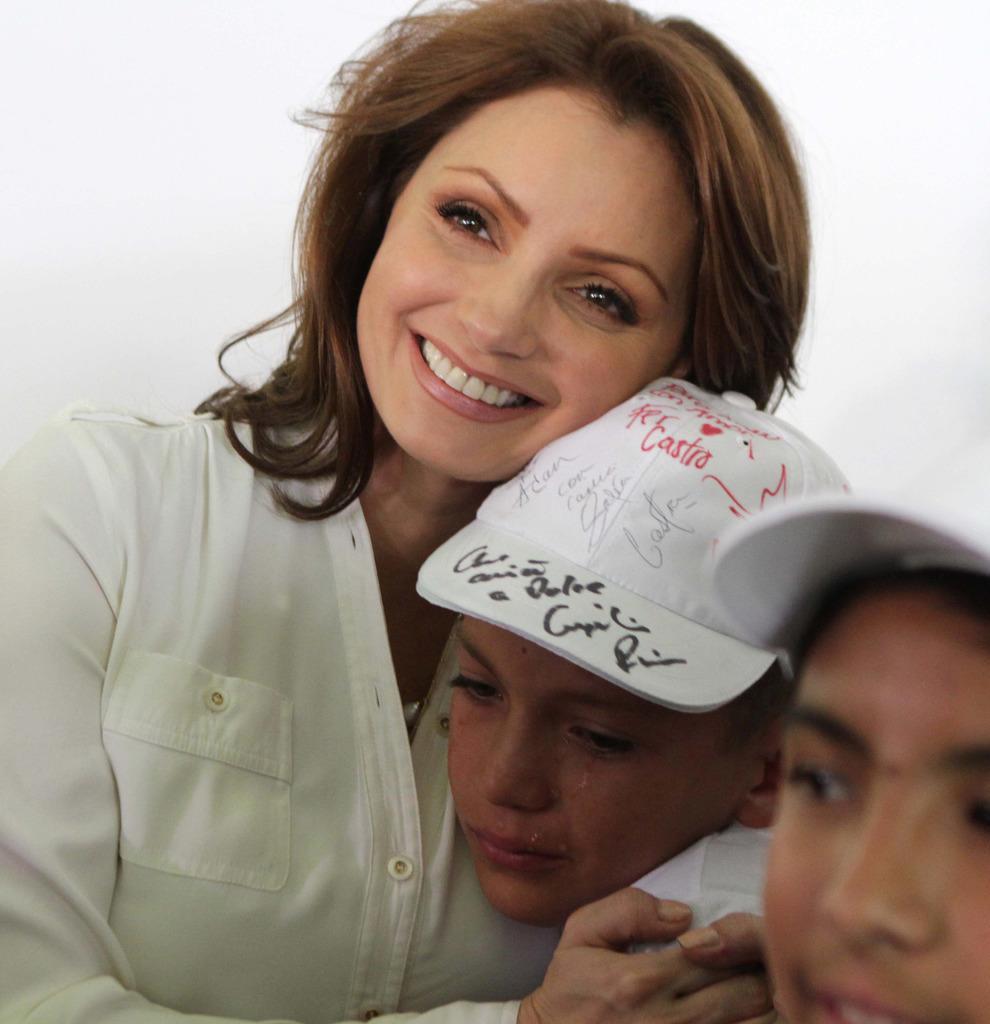In one or two sentences, can you explain what this image depicts? In the image few people are sitting and crying and smiling. 